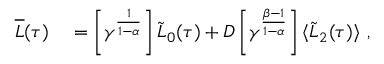<formula> <loc_0><loc_0><loc_500><loc_500>\begin{array} { r l } { \overline { L } ( \tau ) } & = \left [ \gamma ^ { \frac { 1 } { 1 - \alpha } } \right ] \tilde { L } _ { 0 } ( \tau ) + D \left [ \gamma ^ { \frac { \beta - 1 } { 1 - \alpha } } \right ] \langle \tilde { L } _ { 2 } ( \tau ) \rangle \ , } \end{array}</formula> 